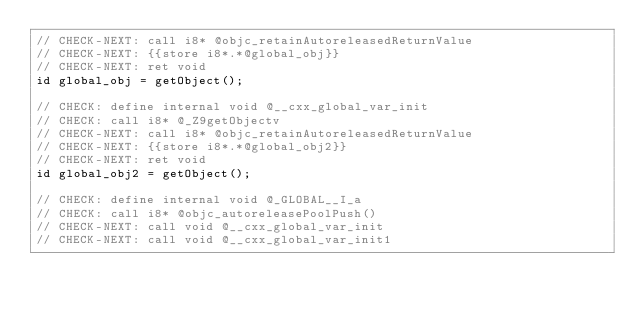<code> <loc_0><loc_0><loc_500><loc_500><_ObjectiveC_>// CHECK-NEXT: call i8* @objc_retainAutoreleasedReturnValue
// CHECK-NEXT: {{store i8*.*@global_obj}}
// CHECK-NEXT: ret void
id global_obj = getObject();

// CHECK: define internal void @__cxx_global_var_init
// CHECK: call i8* @_Z9getObjectv
// CHECK-NEXT: call i8* @objc_retainAutoreleasedReturnValue
// CHECK-NEXT: {{store i8*.*@global_obj2}}
// CHECK-NEXT: ret void
id global_obj2 = getObject();

// CHECK: define internal void @_GLOBAL__I_a
// CHECK: call i8* @objc_autoreleasePoolPush()
// CHECK-NEXT: call void @__cxx_global_var_init
// CHECK-NEXT: call void @__cxx_global_var_init1</code> 